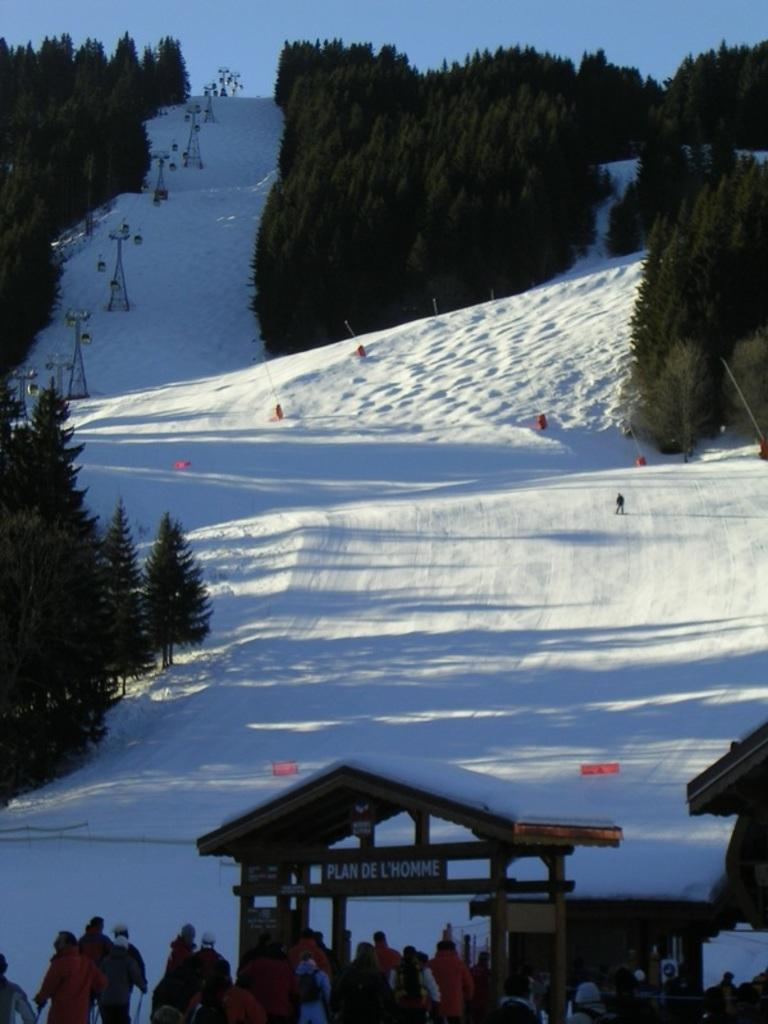What is the main feature of the landscape in the image? There is a mountain covered in snow in the image. What type of vegetation can be seen in the image? There are trees in the image. What structures are present in the image? There are towers in the image. What is the entrance to the area like? There is an entry gate at the bottom of the image. What are the people in the image doing? People are entering the gate. How many copies of the tent are visible in the image? There is no tent present in the image. 